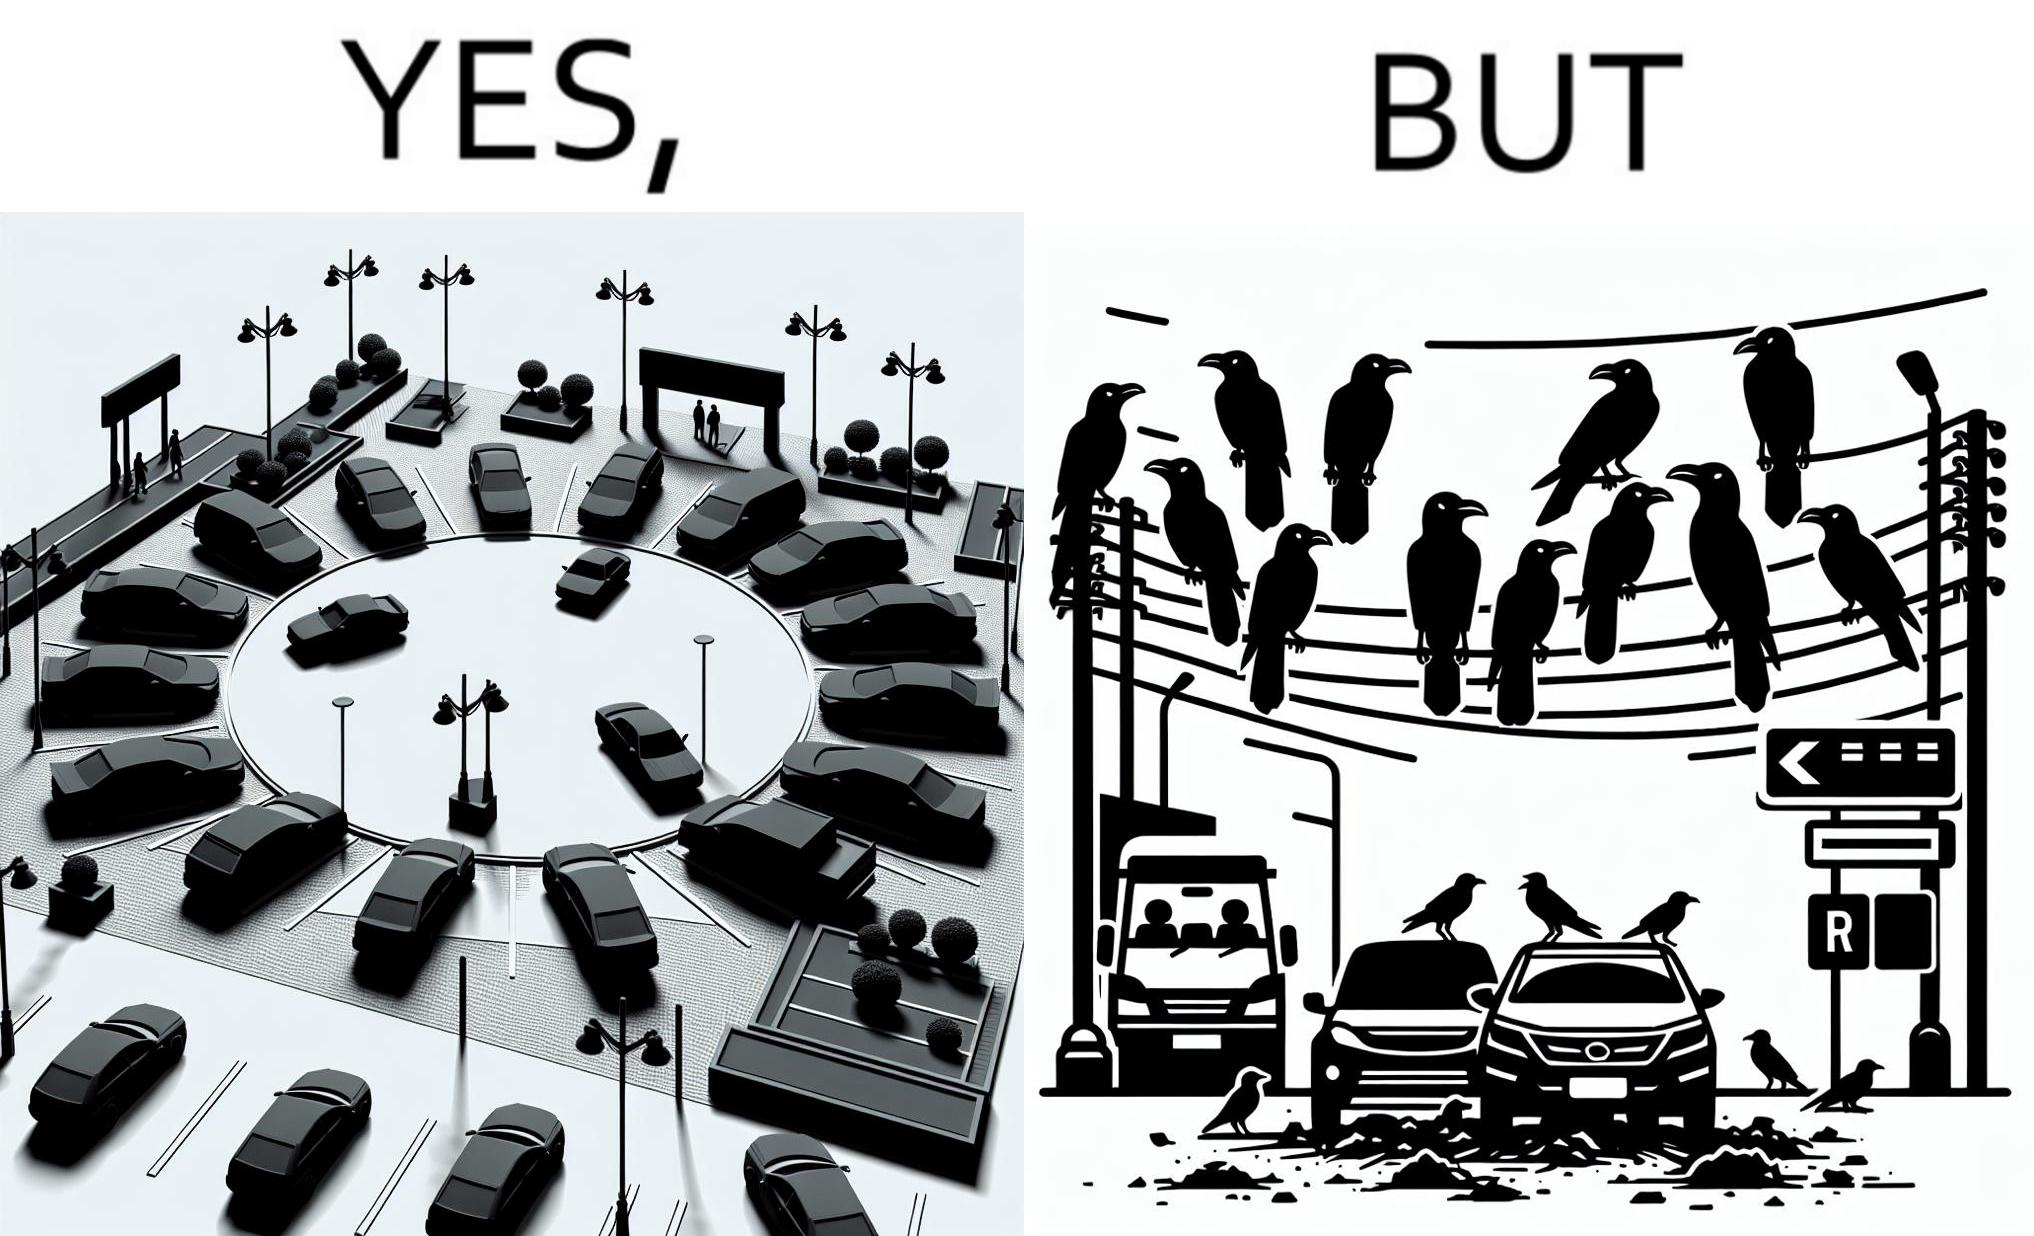Describe what you see in the left and right parts of this image. In the left part of the image: There is a parking place where few cars are standing leaving a place in middle. In the right part of the image: Some crows are sitting on a wire which is above the parking area and the crows are making that place dirty. 